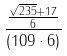Convert formula to latex. <formula><loc_0><loc_0><loc_500><loc_500>\frac { \frac { \sqrt { 2 3 5 } + 1 7 } { 6 } } { ( 1 0 9 \cdot 6 ) }</formula> 